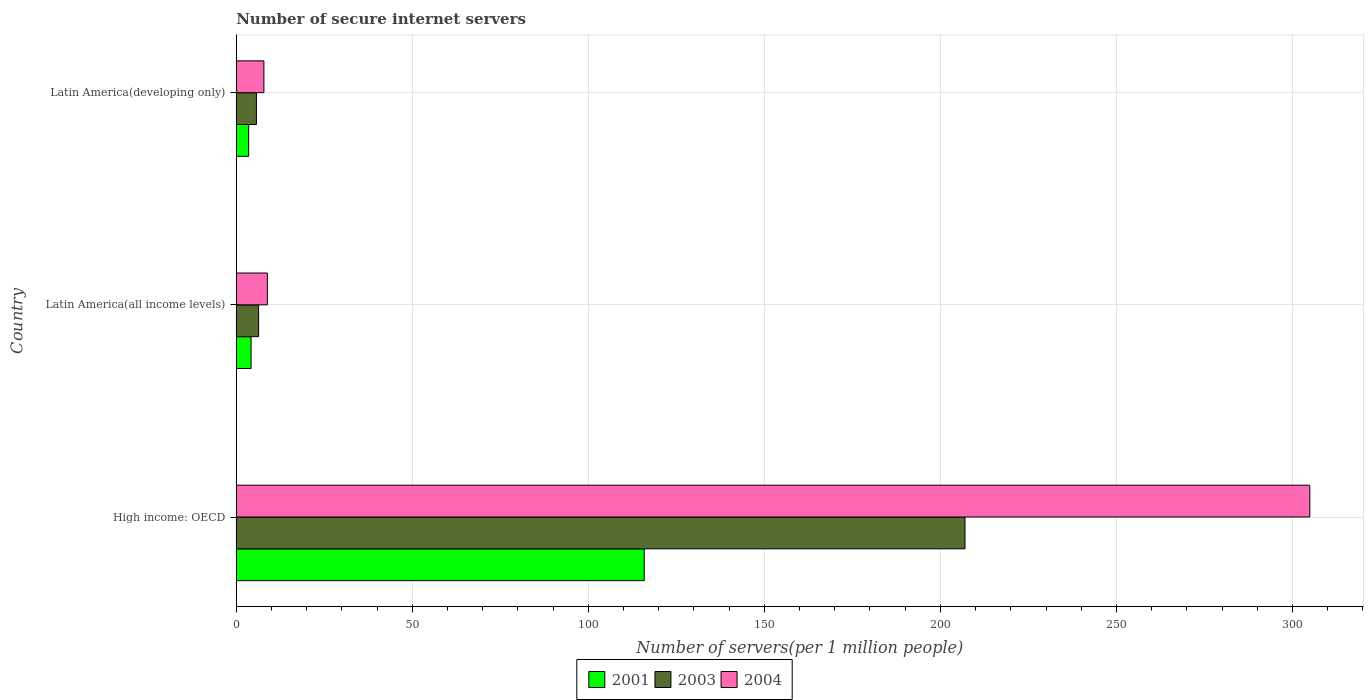How many bars are there on the 1st tick from the bottom?
Keep it short and to the point. 3. What is the label of the 2nd group of bars from the top?
Your answer should be very brief. Latin America(all income levels). In how many cases, is the number of bars for a given country not equal to the number of legend labels?
Keep it short and to the point. 0. What is the number of secure internet servers in 2003 in High income: OECD?
Your response must be concise. 206.98. Across all countries, what is the maximum number of secure internet servers in 2001?
Provide a succinct answer. 115.88. Across all countries, what is the minimum number of secure internet servers in 2004?
Offer a terse response. 7.85. In which country was the number of secure internet servers in 2003 maximum?
Offer a terse response. High income: OECD. In which country was the number of secure internet servers in 2003 minimum?
Provide a short and direct response. Latin America(developing only). What is the total number of secure internet servers in 2003 in the graph?
Your response must be concise. 219.06. What is the difference between the number of secure internet servers in 2004 in Latin America(all income levels) and that in Latin America(developing only)?
Your answer should be compact. 0.98. What is the difference between the number of secure internet servers in 2003 in High income: OECD and the number of secure internet servers in 2001 in Latin America(developing only)?
Provide a short and direct response. 203.46. What is the average number of secure internet servers in 2001 per country?
Make the answer very short. 41.2. What is the difference between the number of secure internet servers in 2004 and number of secure internet servers in 2001 in High income: OECD?
Ensure brevity in your answer.  189.04. In how many countries, is the number of secure internet servers in 2001 greater than 200 ?
Offer a terse response. 0. What is the ratio of the number of secure internet servers in 2004 in Latin America(all income levels) to that in Latin America(developing only)?
Your answer should be compact. 1.12. Is the number of secure internet servers in 2001 in High income: OECD less than that in Latin America(all income levels)?
Ensure brevity in your answer.  No. Is the difference between the number of secure internet servers in 2004 in High income: OECD and Latin America(all income levels) greater than the difference between the number of secure internet servers in 2001 in High income: OECD and Latin America(all income levels)?
Offer a very short reply. Yes. What is the difference between the highest and the second highest number of secure internet servers in 2003?
Offer a very short reply. 200.64. What is the difference between the highest and the lowest number of secure internet servers in 2003?
Your response must be concise. 201.25. In how many countries, is the number of secure internet servers in 2004 greater than the average number of secure internet servers in 2004 taken over all countries?
Provide a short and direct response. 1. Is the sum of the number of secure internet servers in 2004 in High income: OECD and Latin America(developing only) greater than the maximum number of secure internet servers in 2001 across all countries?
Offer a very short reply. Yes. What does the 2nd bar from the top in Latin America(developing only) represents?
Make the answer very short. 2003. What does the 1st bar from the bottom in High income: OECD represents?
Provide a succinct answer. 2001. Is it the case that in every country, the sum of the number of secure internet servers in 2004 and number of secure internet servers in 2001 is greater than the number of secure internet servers in 2003?
Ensure brevity in your answer.  Yes. Are all the bars in the graph horizontal?
Provide a succinct answer. Yes. What is the difference between two consecutive major ticks on the X-axis?
Offer a terse response. 50. Are the values on the major ticks of X-axis written in scientific E-notation?
Provide a short and direct response. No. Does the graph contain any zero values?
Your answer should be very brief. No. Does the graph contain grids?
Offer a terse response. Yes. Where does the legend appear in the graph?
Offer a very short reply. Bottom center. How many legend labels are there?
Offer a very short reply. 3. What is the title of the graph?
Offer a terse response. Number of secure internet servers. What is the label or title of the X-axis?
Your response must be concise. Number of servers(per 1 million people). What is the label or title of the Y-axis?
Provide a short and direct response. Country. What is the Number of servers(per 1 million people) of 2001 in High income: OECD?
Your answer should be compact. 115.88. What is the Number of servers(per 1 million people) of 2003 in High income: OECD?
Ensure brevity in your answer.  206.98. What is the Number of servers(per 1 million people) of 2004 in High income: OECD?
Your answer should be compact. 304.92. What is the Number of servers(per 1 million people) in 2001 in Latin America(all income levels)?
Give a very brief answer. 4.21. What is the Number of servers(per 1 million people) in 2003 in Latin America(all income levels)?
Keep it short and to the point. 6.35. What is the Number of servers(per 1 million people) of 2004 in Latin America(all income levels)?
Ensure brevity in your answer.  8.83. What is the Number of servers(per 1 million people) in 2001 in Latin America(developing only)?
Keep it short and to the point. 3.52. What is the Number of servers(per 1 million people) of 2003 in Latin America(developing only)?
Your answer should be very brief. 5.73. What is the Number of servers(per 1 million people) in 2004 in Latin America(developing only)?
Offer a very short reply. 7.85. Across all countries, what is the maximum Number of servers(per 1 million people) of 2001?
Provide a succinct answer. 115.88. Across all countries, what is the maximum Number of servers(per 1 million people) in 2003?
Provide a succinct answer. 206.98. Across all countries, what is the maximum Number of servers(per 1 million people) of 2004?
Your answer should be very brief. 304.92. Across all countries, what is the minimum Number of servers(per 1 million people) in 2001?
Provide a succinct answer. 3.52. Across all countries, what is the minimum Number of servers(per 1 million people) in 2003?
Give a very brief answer. 5.73. Across all countries, what is the minimum Number of servers(per 1 million people) in 2004?
Make the answer very short. 7.85. What is the total Number of servers(per 1 million people) in 2001 in the graph?
Ensure brevity in your answer.  123.61. What is the total Number of servers(per 1 million people) of 2003 in the graph?
Provide a short and direct response. 219.06. What is the total Number of servers(per 1 million people) of 2004 in the graph?
Provide a short and direct response. 321.6. What is the difference between the Number of servers(per 1 million people) of 2001 in High income: OECD and that in Latin America(all income levels)?
Your response must be concise. 111.67. What is the difference between the Number of servers(per 1 million people) in 2003 in High income: OECD and that in Latin America(all income levels)?
Your answer should be compact. 200.64. What is the difference between the Number of servers(per 1 million people) of 2004 in High income: OECD and that in Latin America(all income levels)?
Give a very brief answer. 296.09. What is the difference between the Number of servers(per 1 million people) of 2001 in High income: OECD and that in Latin America(developing only)?
Keep it short and to the point. 112.36. What is the difference between the Number of servers(per 1 million people) in 2003 in High income: OECD and that in Latin America(developing only)?
Offer a terse response. 201.25. What is the difference between the Number of servers(per 1 million people) of 2004 in High income: OECD and that in Latin America(developing only)?
Your response must be concise. 297.07. What is the difference between the Number of servers(per 1 million people) in 2001 in Latin America(all income levels) and that in Latin America(developing only)?
Your response must be concise. 0.69. What is the difference between the Number of servers(per 1 million people) in 2003 in Latin America(all income levels) and that in Latin America(developing only)?
Your response must be concise. 0.61. What is the difference between the Number of servers(per 1 million people) of 2004 in Latin America(all income levels) and that in Latin America(developing only)?
Your answer should be very brief. 0.98. What is the difference between the Number of servers(per 1 million people) of 2001 in High income: OECD and the Number of servers(per 1 million people) of 2003 in Latin America(all income levels)?
Make the answer very short. 109.53. What is the difference between the Number of servers(per 1 million people) of 2001 in High income: OECD and the Number of servers(per 1 million people) of 2004 in Latin America(all income levels)?
Make the answer very short. 107.05. What is the difference between the Number of servers(per 1 million people) in 2003 in High income: OECD and the Number of servers(per 1 million people) in 2004 in Latin America(all income levels)?
Keep it short and to the point. 198.15. What is the difference between the Number of servers(per 1 million people) in 2001 in High income: OECD and the Number of servers(per 1 million people) in 2003 in Latin America(developing only)?
Offer a very short reply. 110.15. What is the difference between the Number of servers(per 1 million people) in 2001 in High income: OECD and the Number of servers(per 1 million people) in 2004 in Latin America(developing only)?
Offer a very short reply. 108.03. What is the difference between the Number of servers(per 1 million people) in 2003 in High income: OECD and the Number of servers(per 1 million people) in 2004 in Latin America(developing only)?
Give a very brief answer. 199.13. What is the difference between the Number of servers(per 1 million people) of 2001 in Latin America(all income levels) and the Number of servers(per 1 million people) of 2003 in Latin America(developing only)?
Offer a very short reply. -1.52. What is the difference between the Number of servers(per 1 million people) of 2001 in Latin America(all income levels) and the Number of servers(per 1 million people) of 2004 in Latin America(developing only)?
Your answer should be very brief. -3.64. What is the difference between the Number of servers(per 1 million people) of 2003 in Latin America(all income levels) and the Number of servers(per 1 million people) of 2004 in Latin America(developing only)?
Your response must be concise. -1.5. What is the average Number of servers(per 1 million people) of 2001 per country?
Provide a succinct answer. 41.2. What is the average Number of servers(per 1 million people) in 2003 per country?
Make the answer very short. 73.02. What is the average Number of servers(per 1 million people) of 2004 per country?
Keep it short and to the point. 107.2. What is the difference between the Number of servers(per 1 million people) in 2001 and Number of servers(per 1 million people) in 2003 in High income: OECD?
Ensure brevity in your answer.  -91.11. What is the difference between the Number of servers(per 1 million people) in 2001 and Number of servers(per 1 million people) in 2004 in High income: OECD?
Provide a succinct answer. -189.04. What is the difference between the Number of servers(per 1 million people) in 2003 and Number of servers(per 1 million people) in 2004 in High income: OECD?
Ensure brevity in your answer.  -97.94. What is the difference between the Number of servers(per 1 million people) of 2001 and Number of servers(per 1 million people) of 2003 in Latin America(all income levels)?
Offer a very short reply. -2.14. What is the difference between the Number of servers(per 1 million people) in 2001 and Number of servers(per 1 million people) in 2004 in Latin America(all income levels)?
Your response must be concise. -4.62. What is the difference between the Number of servers(per 1 million people) in 2003 and Number of servers(per 1 million people) in 2004 in Latin America(all income levels)?
Offer a terse response. -2.48. What is the difference between the Number of servers(per 1 million people) of 2001 and Number of servers(per 1 million people) of 2003 in Latin America(developing only)?
Offer a very short reply. -2.21. What is the difference between the Number of servers(per 1 million people) of 2001 and Number of servers(per 1 million people) of 2004 in Latin America(developing only)?
Your answer should be compact. -4.33. What is the difference between the Number of servers(per 1 million people) of 2003 and Number of servers(per 1 million people) of 2004 in Latin America(developing only)?
Your response must be concise. -2.12. What is the ratio of the Number of servers(per 1 million people) in 2001 in High income: OECD to that in Latin America(all income levels)?
Your response must be concise. 27.53. What is the ratio of the Number of servers(per 1 million people) in 2003 in High income: OECD to that in Latin America(all income levels)?
Your answer should be very brief. 32.62. What is the ratio of the Number of servers(per 1 million people) in 2004 in High income: OECD to that in Latin America(all income levels)?
Make the answer very short. 34.53. What is the ratio of the Number of servers(per 1 million people) in 2001 in High income: OECD to that in Latin America(developing only)?
Ensure brevity in your answer.  32.9. What is the ratio of the Number of servers(per 1 million people) of 2003 in High income: OECD to that in Latin America(developing only)?
Ensure brevity in your answer.  36.11. What is the ratio of the Number of servers(per 1 million people) in 2004 in High income: OECD to that in Latin America(developing only)?
Provide a short and direct response. 38.84. What is the ratio of the Number of servers(per 1 million people) in 2001 in Latin America(all income levels) to that in Latin America(developing only)?
Provide a short and direct response. 1.19. What is the ratio of the Number of servers(per 1 million people) in 2003 in Latin America(all income levels) to that in Latin America(developing only)?
Your answer should be very brief. 1.11. What is the ratio of the Number of servers(per 1 million people) of 2004 in Latin America(all income levels) to that in Latin America(developing only)?
Your answer should be compact. 1.12. What is the difference between the highest and the second highest Number of servers(per 1 million people) in 2001?
Offer a terse response. 111.67. What is the difference between the highest and the second highest Number of servers(per 1 million people) in 2003?
Your answer should be compact. 200.64. What is the difference between the highest and the second highest Number of servers(per 1 million people) of 2004?
Provide a short and direct response. 296.09. What is the difference between the highest and the lowest Number of servers(per 1 million people) in 2001?
Make the answer very short. 112.36. What is the difference between the highest and the lowest Number of servers(per 1 million people) of 2003?
Ensure brevity in your answer.  201.25. What is the difference between the highest and the lowest Number of servers(per 1 million people) in 2004?
Provide a succinct answer. 297.07. 